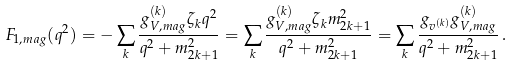<formula> <loc_0><loc_0><loc_500><loc_500>F _ { 1 , m a g } ( q ^ { 2 } ) = - \sum _ { k } \frac { g ^ { ( k ) } _ { V , m a g } \zeta _ { k } q ^ { 2 } } { q ^ { 2 } + m _ { 2 k + 1 } ^ { 2 } } = \sum _ { k } \frac { g ^ { ( k ) } _ { V , m a g } \zeta _ { k } m _ { 2 k + 1 } ^ { 2 } } { q ^ { 2 } + m _ { 2 k + 1 } ^ { 2 } } = \sum _ { k } \frac { g _ { v ^ { ( k ) } } g ^ { ( k ) } _ { V , m a g } } { q ^ { 2 } + m _ { 2 k + 1 } ^ { 2 } } \, .</formula> 